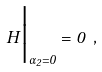Convert formula to latex. <formula><loc_0><loc_0><loc_500><loc_500>H \Big | _ { \alpha _ { 2 } = 0 } = 0 \ ,</formula> 